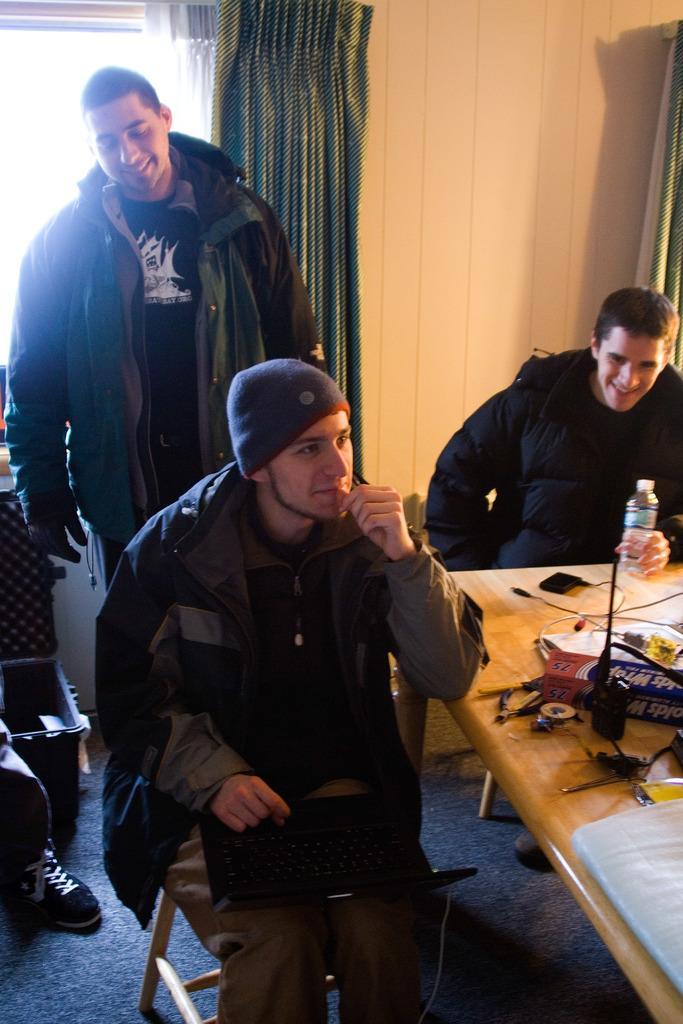How would you summarize this image in a sentence or two? In this image I see 3 men in which these 2 are siting and this guy is standing, I can also see that these 2 are smiling and there is a table in front of them, on which there are few things. In the background I see the window, curtains and a person's leg over here 